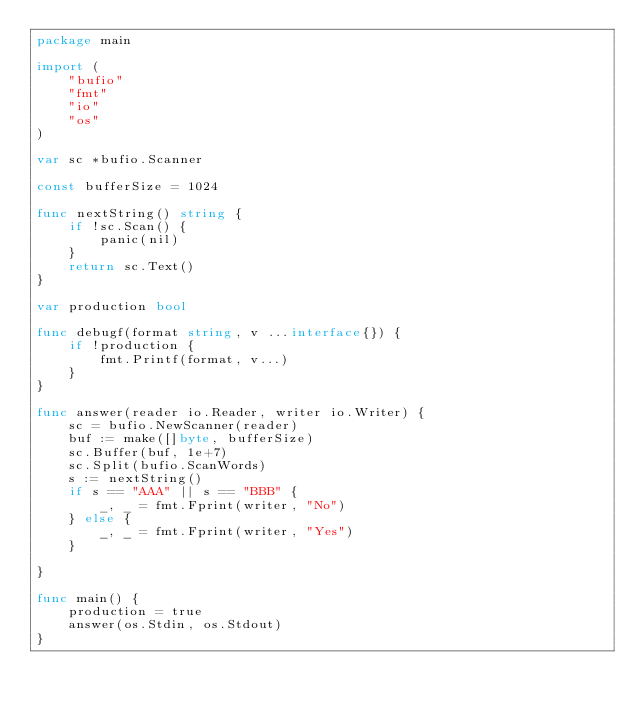<code> <loc_0><loc_0><loc_500><loc_500><_Go_>package main

import (
	"bufio"
	"fmt"
	"io"
	"os"
)

var sc *bufio.Scanner

const bufferSize = 1024

func nextString() string {
	if !sc.Scan() {
		panic(nil)
	}
	return sc.Text()
}

var production bool

func debugf(format string, v ...interface{}) {
	if !production {
		fmt.Printf(format, v...)
	}
}

func answer(reader io.Reader, writer io.Writer) {
	sc = bufio.NewScanner(reader)
	buf := make([]byte, bufferSize)
	sc.Buffer(buf, 1e+7)
	sc.Split(bufio.ScanWords)
	s := nextString()
	if s == "AAA" || s == "BBB" {
		_, _ = fmt.Fprint(writer, "No")
	} else {
		_, _ = fmt.Fprint(writer, "Yes")
	}

}

func main() {
	production = true
	answer(os.Stdin, os.Stdout)
}
</code> 